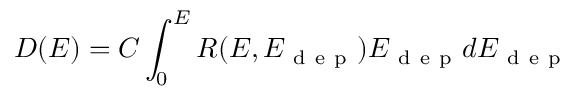<formula> <loc_0><loc_0><loc_500><loc_500>D ( E ) = C \int _ { 0 } ^ { E } R ( E , E _ { d e p } ) E _ { d e p } d E _ { d e p }</formula> 